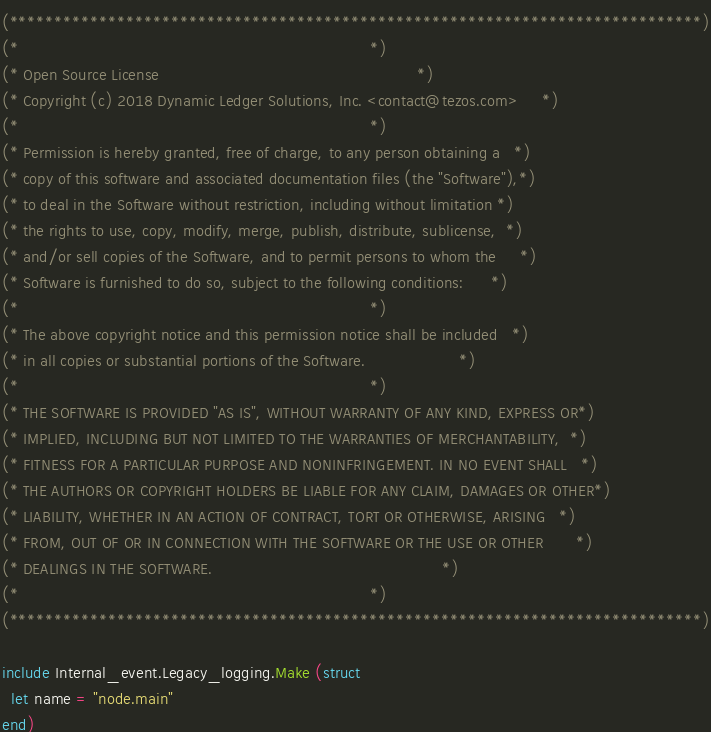<code> <loc_0><loc_0><loc_500><loc_500><_OCaml_>(*****************************************************************************)
(*                                                                           *)
(* Open Source License                                                       *)
(* Copyright (c) 2018 Dynamic Ledger Solutions, Inc. <contact@tezos.com>     *)
(*                                                                           *)
(* Permission is hereby granted, free of charge, to any person obtaining a   *)
(* copy of this software and associated documentation files (the "Software"),*)
(* to deal in the Software without restriction, including without limitation *)
(* the rights to use, copy, modify, merge, publish, distribute, sublicense,  *)
(* and/or sell copies of the Software, and to permit persons to whom the     *)
(* Software is furnished to do so, subject to the following conditions:      *)
(*                                                                           *)
(* The above copyright notice and this permission notice shall be included   *)
(* in all copies or substantial portions of the Software.                    *)
(*                                                                           *)
(* THE SOFTWARE IS PROVIDED "AS IS", WITHOUT WARRANTY OF ANY KIND, EXPRESS OR*)
(* IMPLIED, INCLUDING BUT NOT LIMITED TO THE WARRANTIES OF MERCHANTABILITY,  *)
(* FITNESS FOR A PARTICULAR PURPOSE AND NONINFRINGEMENT. IN NO EVENT SHALL   *)
(* THE AUTHORS OR COPYRIGHT HOLDERS BE LIABLE FOR ANY CLAIM, DAMAGES OR OTHER*)
(* LIABILITY, WHETHER IN AN ACTION OF CONTRACT, TORT OR OTHERWISE, ARISING   *)
(* FROM, OUT OF OR IN CONNECTION WITH THE SOFTWARE OR THE USE OR OTHER       *)
(* DEALINGS IN THE SOFTWARE.                                                 *)
(*                                                                           *)
(*****************************************************************************)

include Internal_event.Legacy_logging.Make (struct
  let name = "node.main"
end)
</code> 